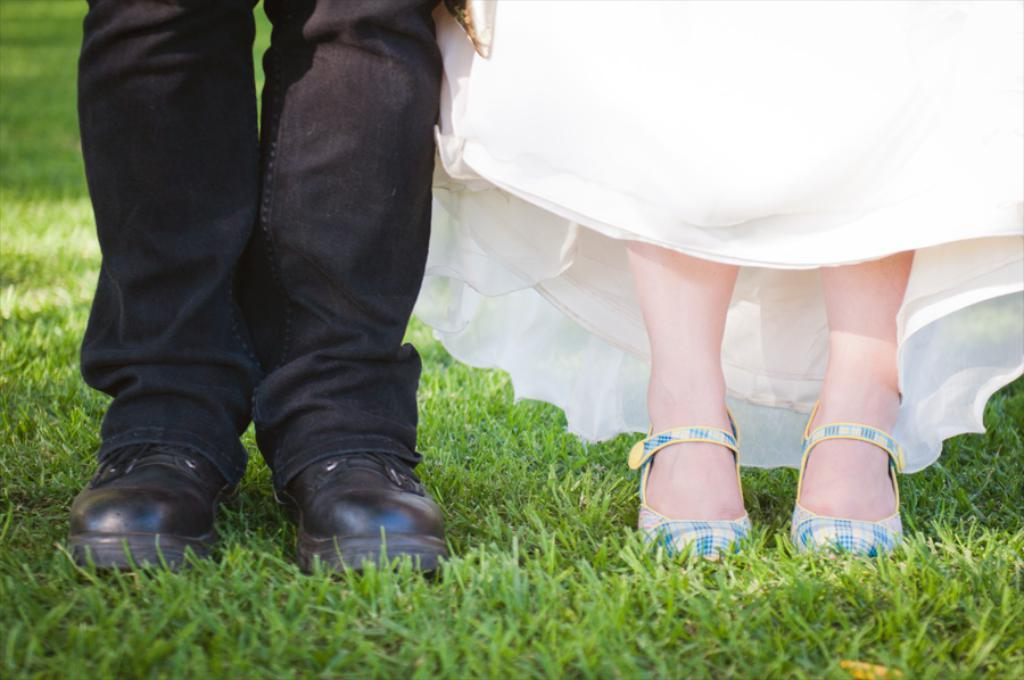How many people are in the image? There are two persons in the image. Where is the person on the left side located? The person on the left side is on the left side of the image. What is the person on the left side wearing? The person on the left side is wearing shoes. What type of terrain is visible at the bottom of the image? There is grass visible at the bottom of the image. What is the person on the right side's belief about the toad in the image? There is no toad present in the image, so it is not possible to determine any beliefs about a toad. 